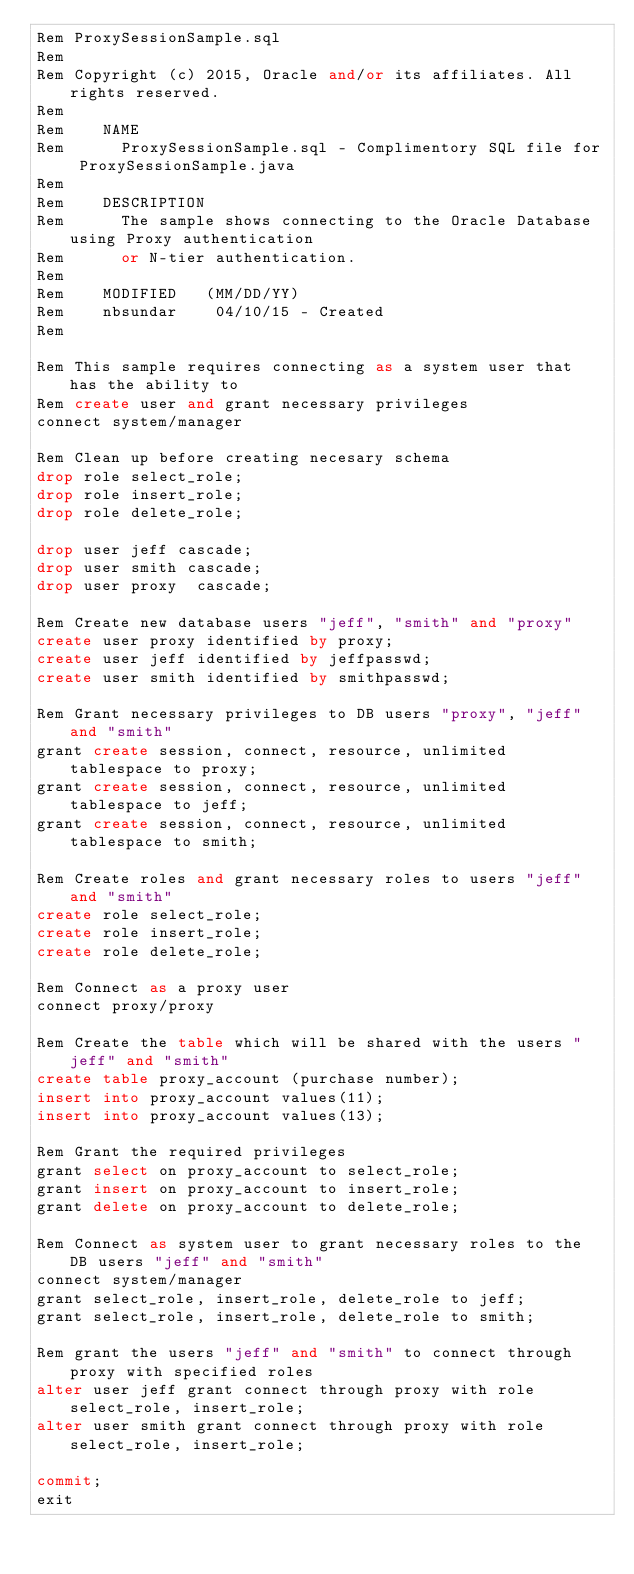<code> <loc_0><loc_0><loc_500><loc_500><_SQL_>Rem ProxySessionSample.sql
Rem
Rem Copyright (c) 2015, Oracle and/or its affiliates. All rights reserved.
Rem
Rem    NAME
Rem      ProxySessionSample.sql - Complimentory SQL file for ProxySessionSample.java
Rem
Rem    DESCRIPTION
Rem      The sample shows connecting to the Oracle Database using Proxy authentication
Rem      or N-tier authentication.
Rem
Rem    MODIFIED   (MM/DD/YY)
Rem    nbsundar    04/10/15 - Created
Rem

Rem This sample requires connecting as a system user that has the ability to
Rem create user and grant necessary privileges
connect system/manager

Rem Clean up before creating necesary schema
drop role select_role;
drop role insert_role;
drop role delete_role;

drop user jeff cascade;
drop user smith cascade;
drop user proxy  cascade;

Rem Create new database users "jeff", "smith" and "proxy" 
create user proxy identified by proxy;
create user jeff identified by jeffpasswd;
create user smith identified by smithpasswd;

Rem Grant necessary privileges to DB users "proxy", "jeff" and "smith" 
grant create session, connect, resource, unlimited tablespace to proxy;
grant create session, connect, resource, unlimited tablespace to jeff;
grant create session, connect, resource, unlimited tablespace to smith;

Rem Create roles and grant necessary roles to users "jeff" and "smith"
create role select_role;
create role insert_role;
create role delete_role;

Rem Connect as a proxy user 
connect proxy/proxy

Rem Create the table which will be shared with the users "jeff" and "smith"
create table proxy_account (purchase number);
insert into proxy_account values(11);
insert into proxy_account values(13);

Rem Grant the required privileges
grant select on proxy_account to select_role;
grant insert on proxy_account to insert_role;
grant delete on proxy_account to delete_role;

Rem Connect as system user to grant necessary roles to the DB users "jeff" and "smith"
connect system/manager
grant select_role, insert_role, delete_role to jeff;
grant select_role, insert_role, delete_role to smith;

Rem grant the users "jeff" and "smith" to connect through proxy with specified roles
alter user jeff grant connect through proxy with role select_role, insert_role;
alter user smith grant connect through proxy with role select_role, insert_role;

commit;
exit

</code> 